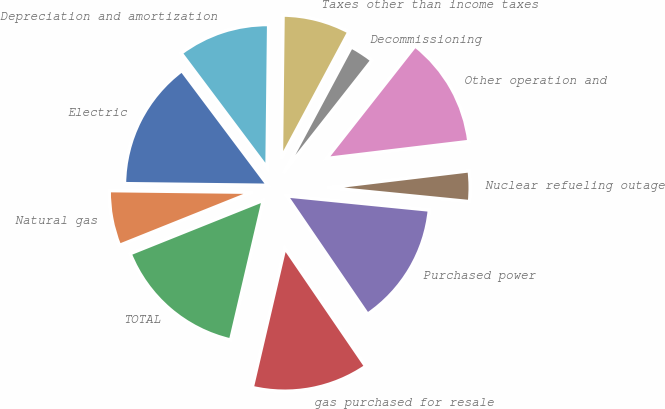Convert chart. <chart><loc_0><loc_0><loc_500><loc_500><pie_chart><fcel>Electric<fcel>Natural gas<fcel>TOTAL<fcel>gas purchased for resale<fcel>Purchased power<fcel>Nuclear refueling outage<fcel>Other operation and<fcel>Decommissioning<fcel>Taxes other than income taxes<fcel>Depreciation and amortization<nl><fcel>14.58%<fcel>6.25%<fcel>15.28%<fcel>13.19%<fcel>13.89%<fcel>3.47%<fcel>12.5%<fcel>2.78%<fcel>7.64%<fcel>10.42%<nl></chart> 